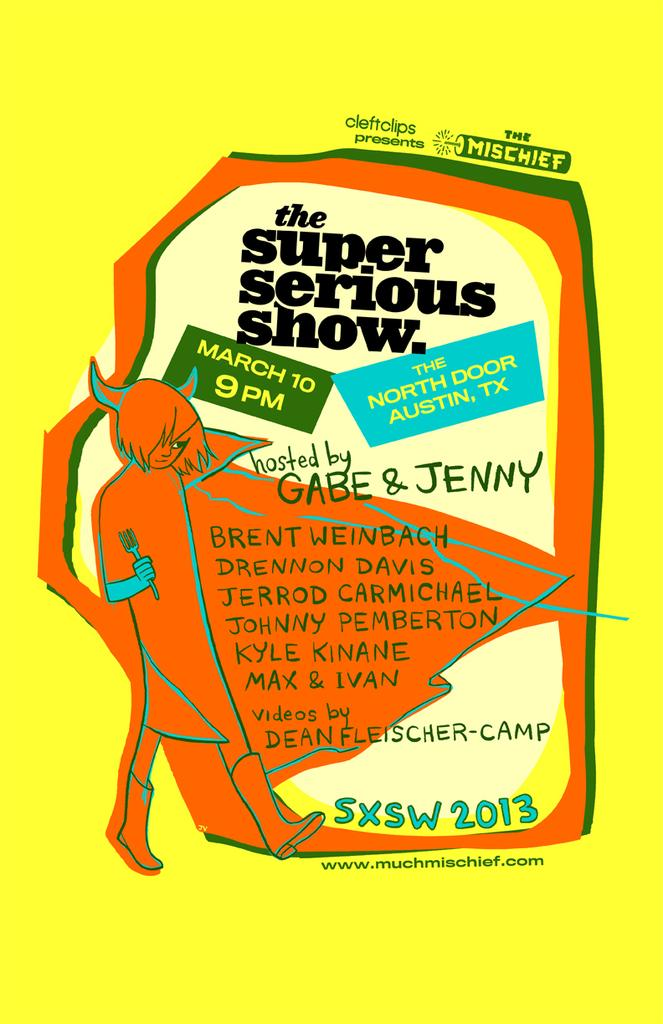<image>
Present a compact description of the photo's key features. Gabe and Jenny host the super serious show 